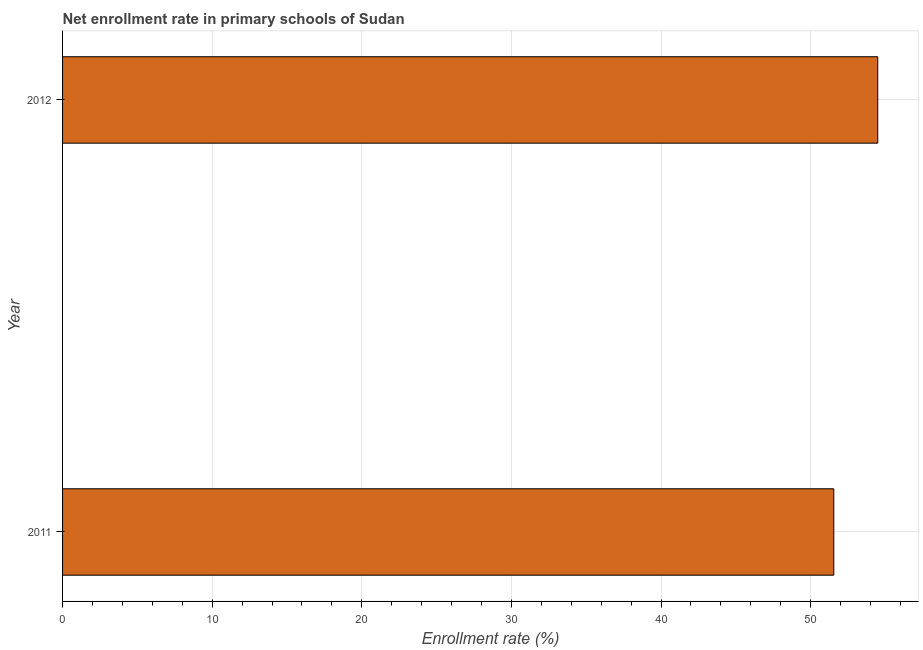Does the graph contain any zero values?
Offer a very short reply. No. Does the graph contain grids?
Give a very brief answer. Yes. What is the title of the graph?
Keep it short and to the point. Net enrollment rate in primary schools of Sudan. What is the label or title of the X-axis?
Provide a short and direct response. Enrollment rate (%). What is the net enrollment rate in primary schools in 2011?
Give a very brief answer. 51.55. Across all years, what is the maximum net enrollment rate in primary schools?
Offer a terse response. 54.49. Across all years, what is the minimum net enrollment rate in primary schools?
Make the answer very short. 51.55. What is the sum of the net enrollment rate in primary schools?
Your response must be concise. 106.04. What is the difference between the net enrollment rate in primary schools in 2011 and 2012?
Make the answer very short. -2.94. What is the average net enrollment rate in primary schools per year?
Give a very brief answer. 53.02. What is the median net enrollment rate in primary schools?
Provide a succinct answer. 53.02. Do a majority of the years between 2011 and 2012 (inclusive) have net enrollment rate in primary schools greater than 10 %?
Your response must be concise. Yes. What is the ratio of the net enrollment rate in primary schools in 2011 to that in 2012?
Your response must be concise. 0.95. How many bars are there?
Keep it short and to the point. 2. How many years are there in the graph?
Your answer should be very brief. 2. What is the difference between two consecutive major ticks on the X-axis?
Provide a succinct answer. 10. Are the values on the major ticks of X-axis written in scientific E-notation?
Your answer should be compact. No. What is the Enrollment rate (%) in 2011?
Your answer should be compact. 51.55. What is the Enrollment rate (%) of 2012?
Your answer should be very brief. 54.49. What is the difference between the Enrollment rate (%) in 2011 and 2012?
Your response must be concise. -2.94. What is the ratio of the Enrollment rate (%) in 2011 to that in 2012?
Your response must be concise. 0.95. 